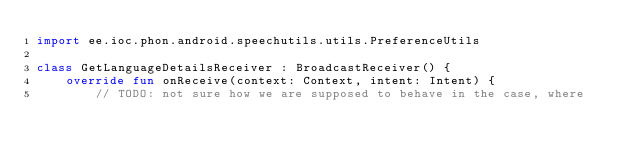Convert code to text. <code><loc_0><loc_0><loc_500><loc_500><_Kotlin_>import ee.ioc.phon.android.speechutils.utils.PreferenceUtils

class GetLanguageDetailsReceiver : BroadcastReceiver() {
    override fun onReceive(context: Context, intent: Intent) {
        // TODO: not sure how we are supposed to behave in the case, where</code> 